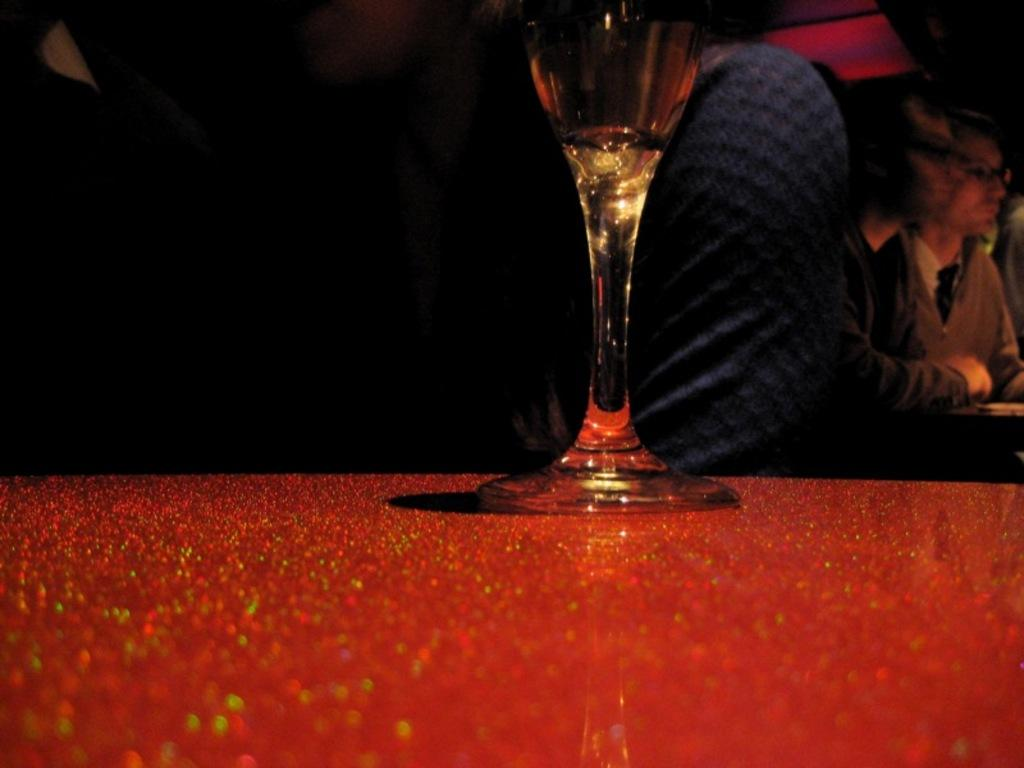What is in the glass that is visible in the image? There is a glass of wine in the image. What is the color of the table on which the glass of wine is placed? The table is red and shiny. Can you describe the people in the background of the image? There are people sitting in the background of the image. What type of fuel is being used by the airplane in the image? There is no airplane present in the image, so it is not possible to determine what type of fuel might be used. 